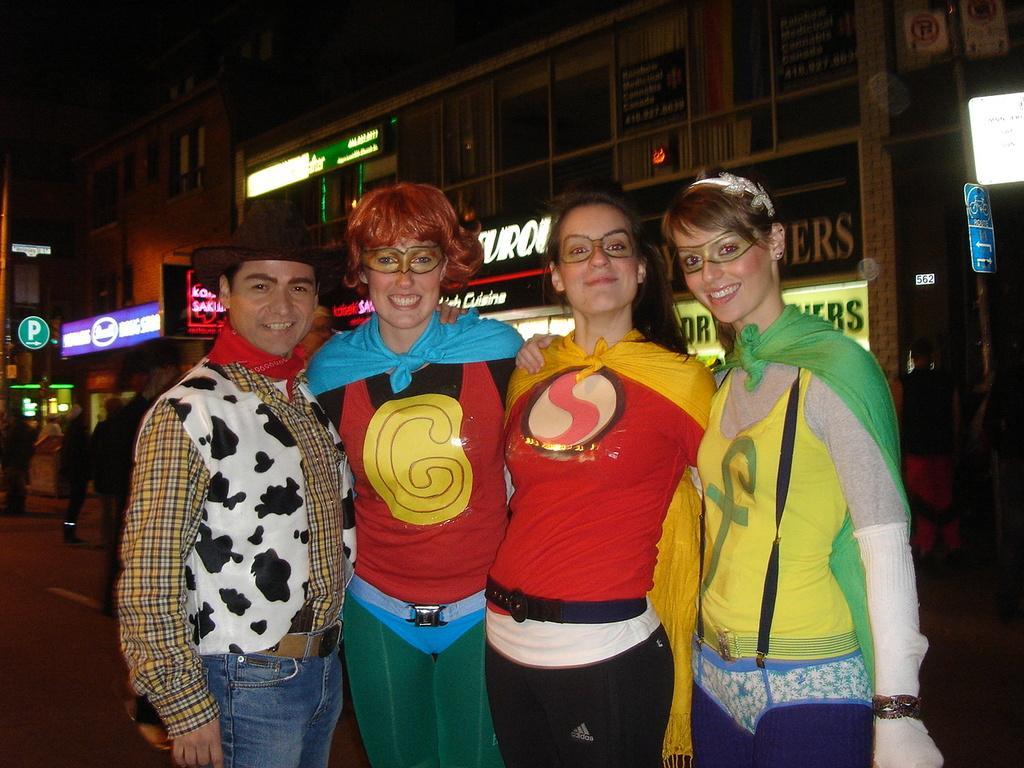Can you describe this image briefly? In this image there are people standing. In the background there are buildings and we can see boards. 